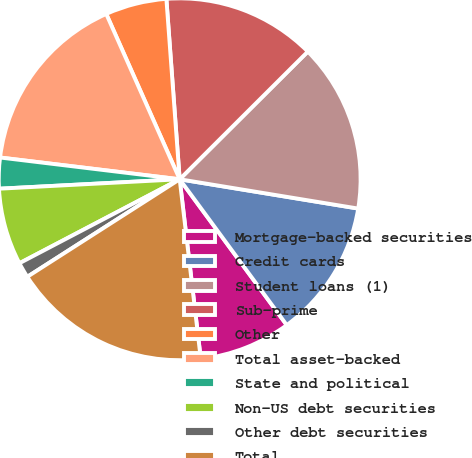Convert chart to OTSL. <chart><loc_0><loc_0><loc_500><loc_500><pie_chart><fcel>Mortgage-backed securities<fcel>Credit cards<fcel>Student loans (1)<fcel>Sub-prime<fcel>Other<fcel>Total asset-backed<fcel>State and political<fcel>Non-US debt securities<fcel>Other debt securities<fcel>Total<nl><fcel>8.22%<fcel>12.33%<fcel>15.06%<fcel>13.7%<fcel>5.48%<fcel>16.43%<fcel>2.75%<fcel>6.85%<fcel>1.38%<fcel>17.8%<nl></chart> 